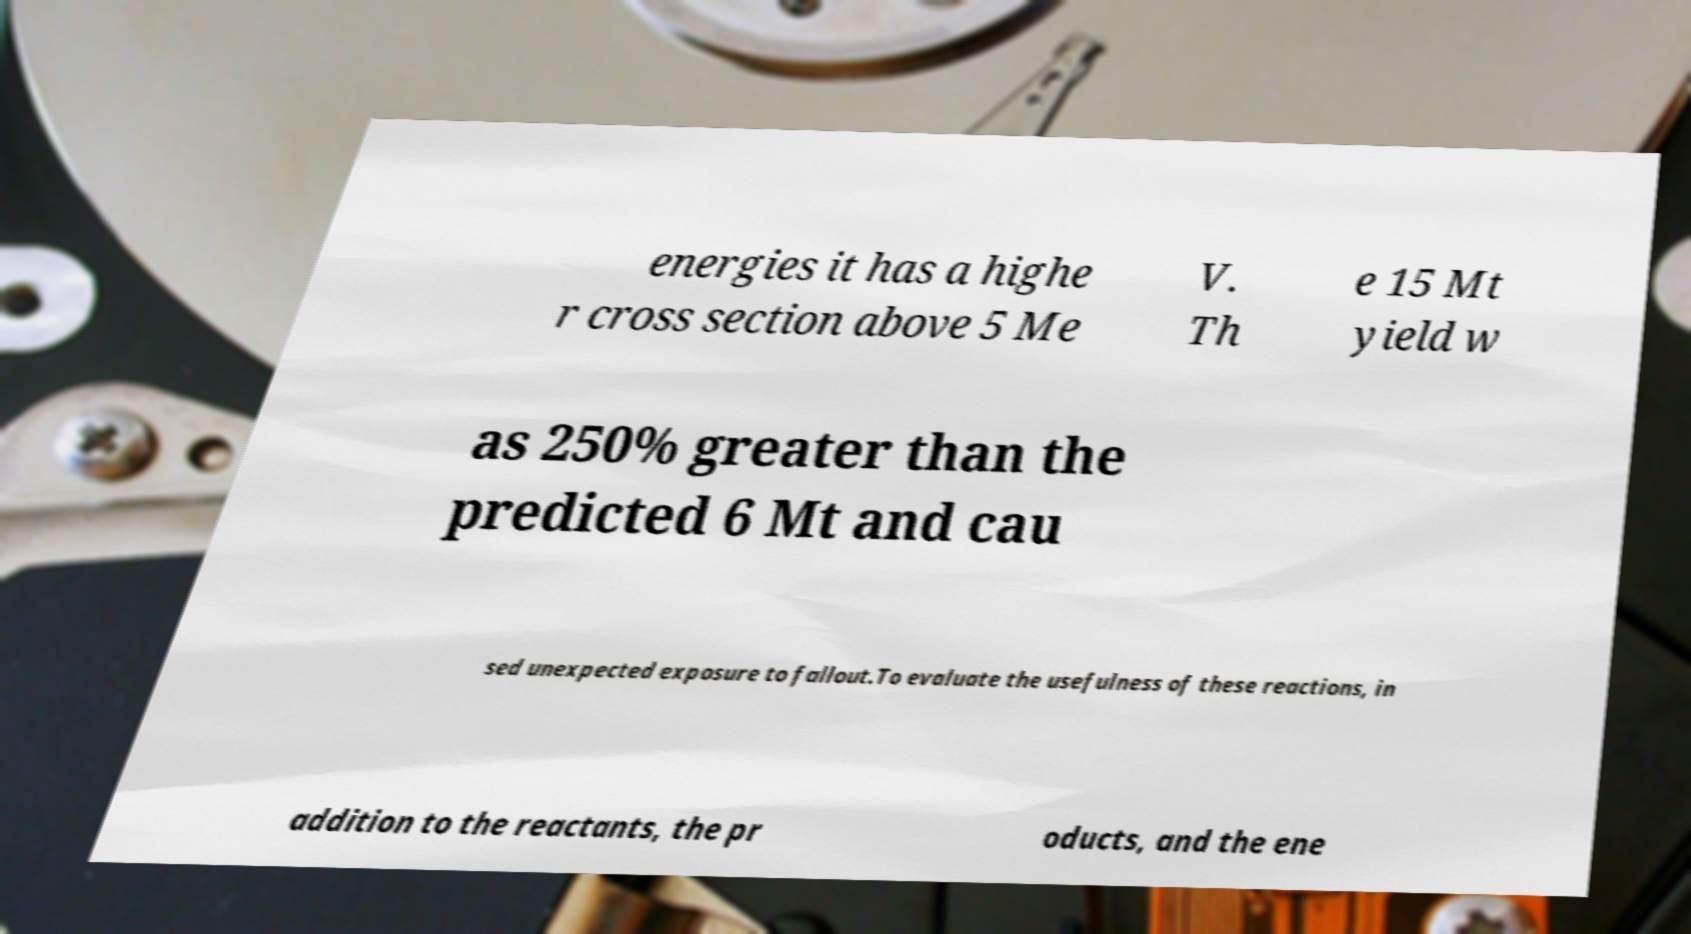Please identify and transcribe the text found in this image. energies it has a highe r cross section above 5 Me V. Th e 15 Mt yield w as 250% greater than the predicted 6 Mt and cau sed unexpected exposure to fallout.To evaluate the usefulness of these reactions, in addition to the reactants, the pr oducts, and the ene 